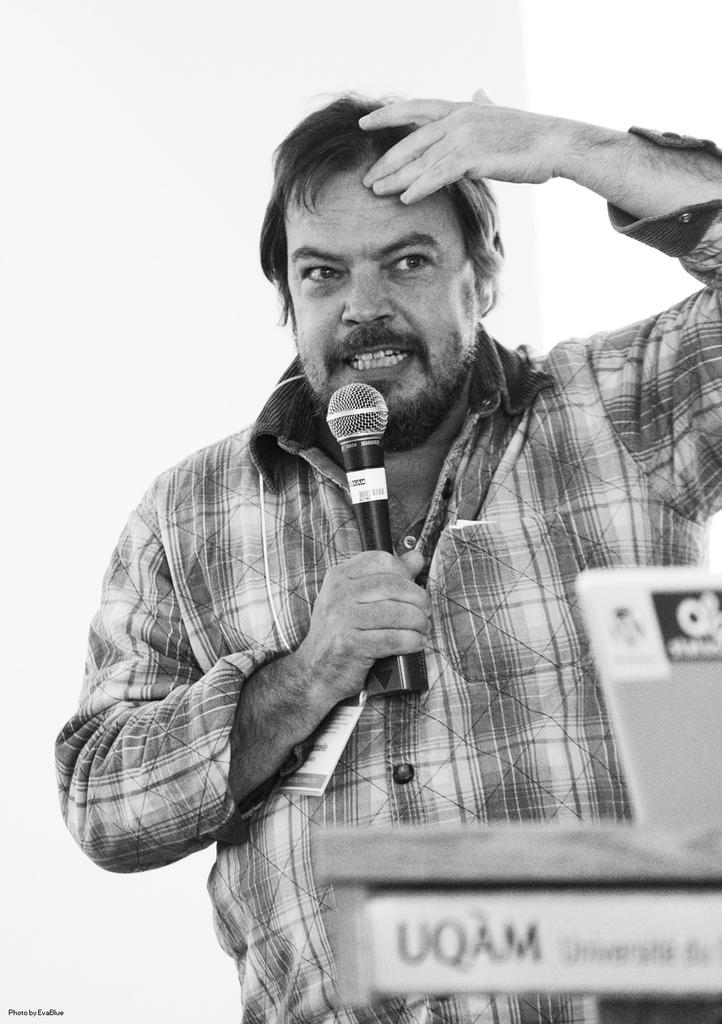What is the main subject of the image? The main subject of the image is a man. What is the man doing in the image? The man is standing in the image. What object is the man holding in the image? The man is holding a mic in the image. What type of ornament is hanging from the man's ear in the image? There is no ornament hanging from the man's ear in the image; he is only holding a mic. How many muscles can be seen on the man's arm in the image? The image does not provide enough detail to count the man's muscles, and it is not relevant to the main subject of the image. 